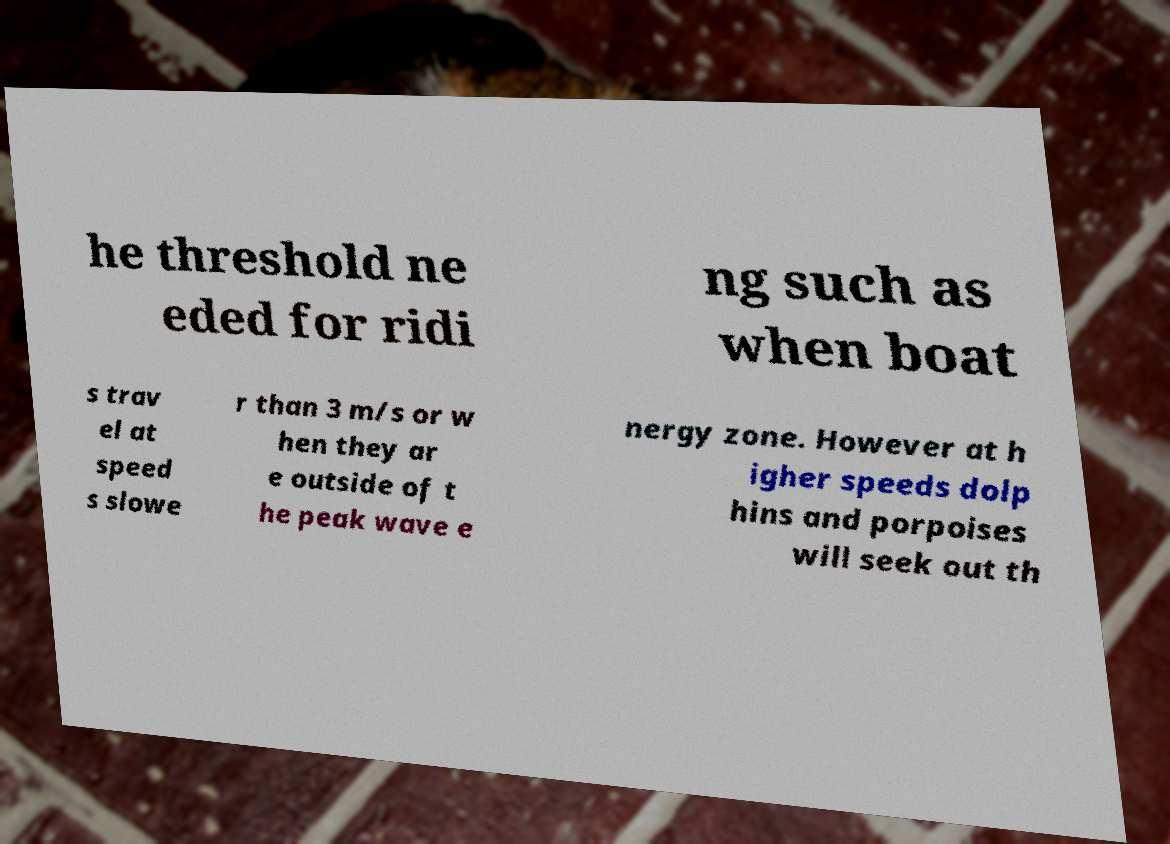I need the written content from this picture converted into text. Can you do that? he threshold ne eded for ridi ng such as when boat s trav el at speed s slowe r than 3 m/s or w hen they ar e outside of t he peak wave e nergy zone. However at h igher speeds dolp hins and porpoises will seek out th 